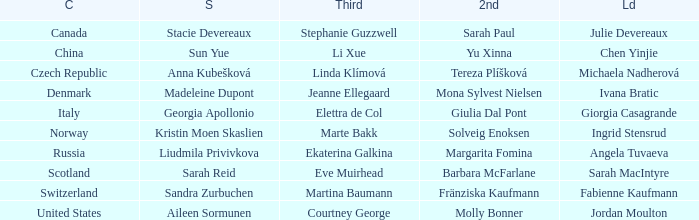What skip has angela tuvaeva as the lead? Liudmila Privivkova. 